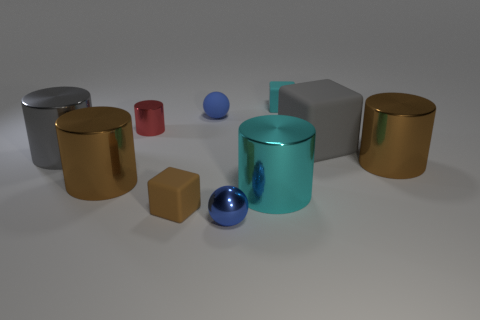Subtract all cyan cylinders. How many cylinders are left? 4 Subtract all large cyan metallic cylinders. How many cylinders are left? 4 Subtract all purple cylinders. Subtract all purple balls. How many cylinders are left? 5 Subtract all cubes. How many objects are left? 7 Add 8 small green things. How many small green things exist? 8 Subtract 1 cyan cylinders. How many objects are left? 9 Subtract all tiny brown matte cubes. Subtract all cyan blocks. How many objects are left? 8 Add 8 tiny metal spheres. How many tiny metal spheres are left? 9 